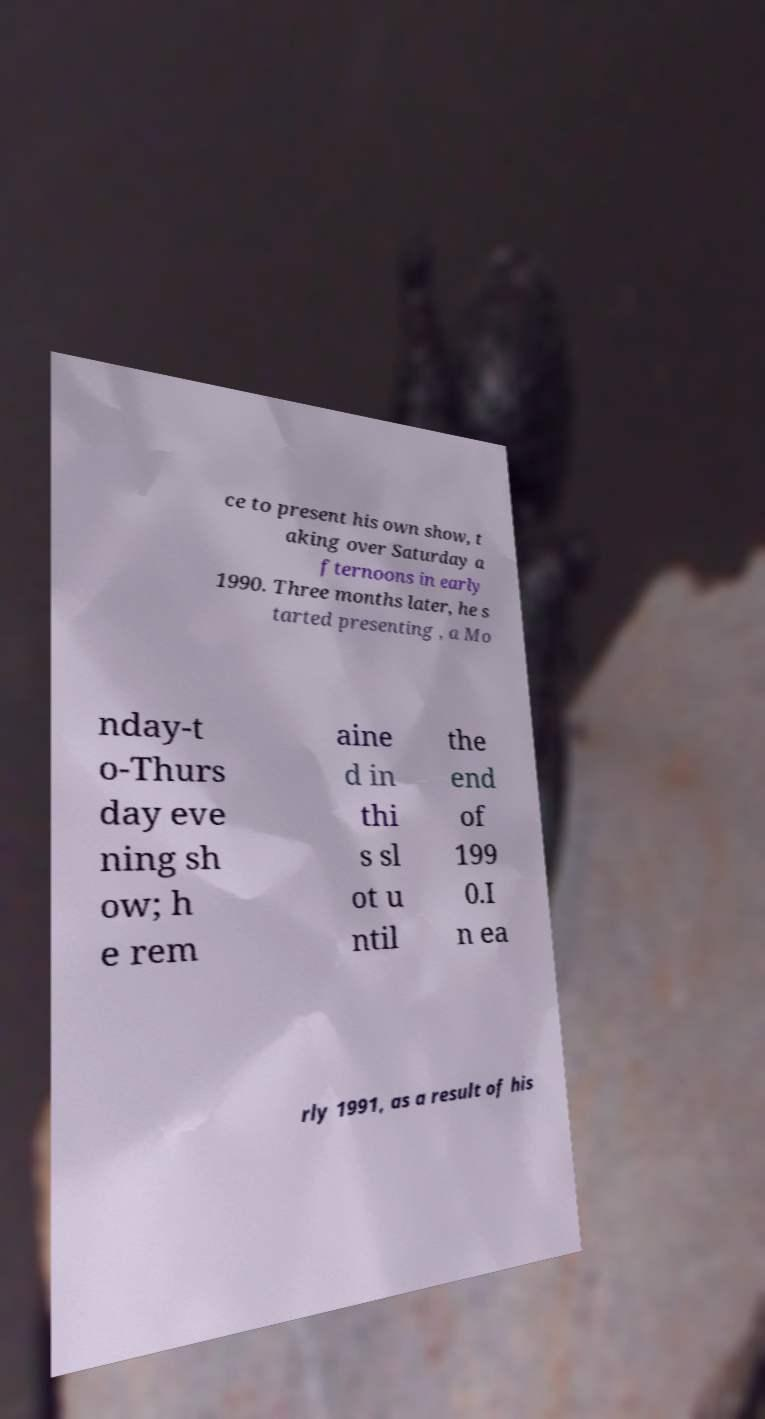I need the written content from this picture converted into text. Can you do that? ce to present his own show, t aking over Saturday a fternoons in early 1990. Three months later, he s tarted presenting , a Mo nday-t o-Thurs day eve ning sh ow; h e rem aine d in thi s sl ot u ntil the end of 199 0.I n ea rly 1991, as a result of his 